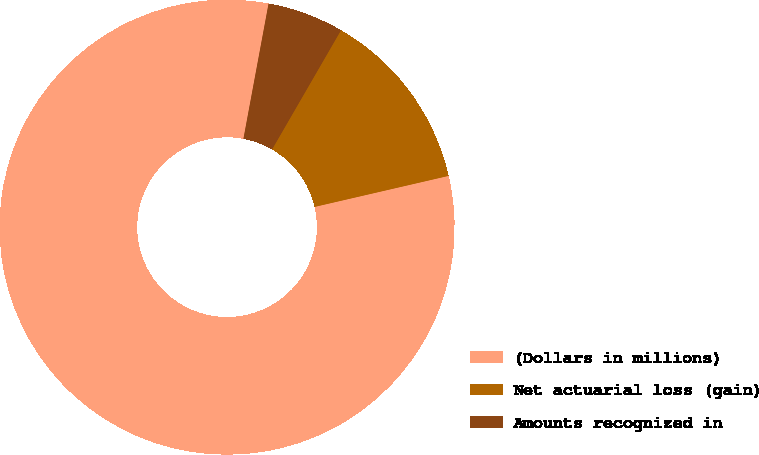<chart> <loc_0><loc_0><loc_500><loc_500><pie_chart><fcel>(Dollars in millions)<fcel>Net actuarial loss (gain)<fcel>Amounts recognized in<nl><fcel>81.54%<fcel>13.03%<fcel>5.42%<nl></chart> 